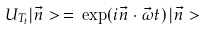Convert formula to latex. <formula><loc_0><loc_0><loc_500><loc_500>U _ { T _ { t } } | \vec { n } > \, = \, \exp ( i \vec { n } \cdot \vec { \omega } t ) \, | \vec { n } ></formula> 